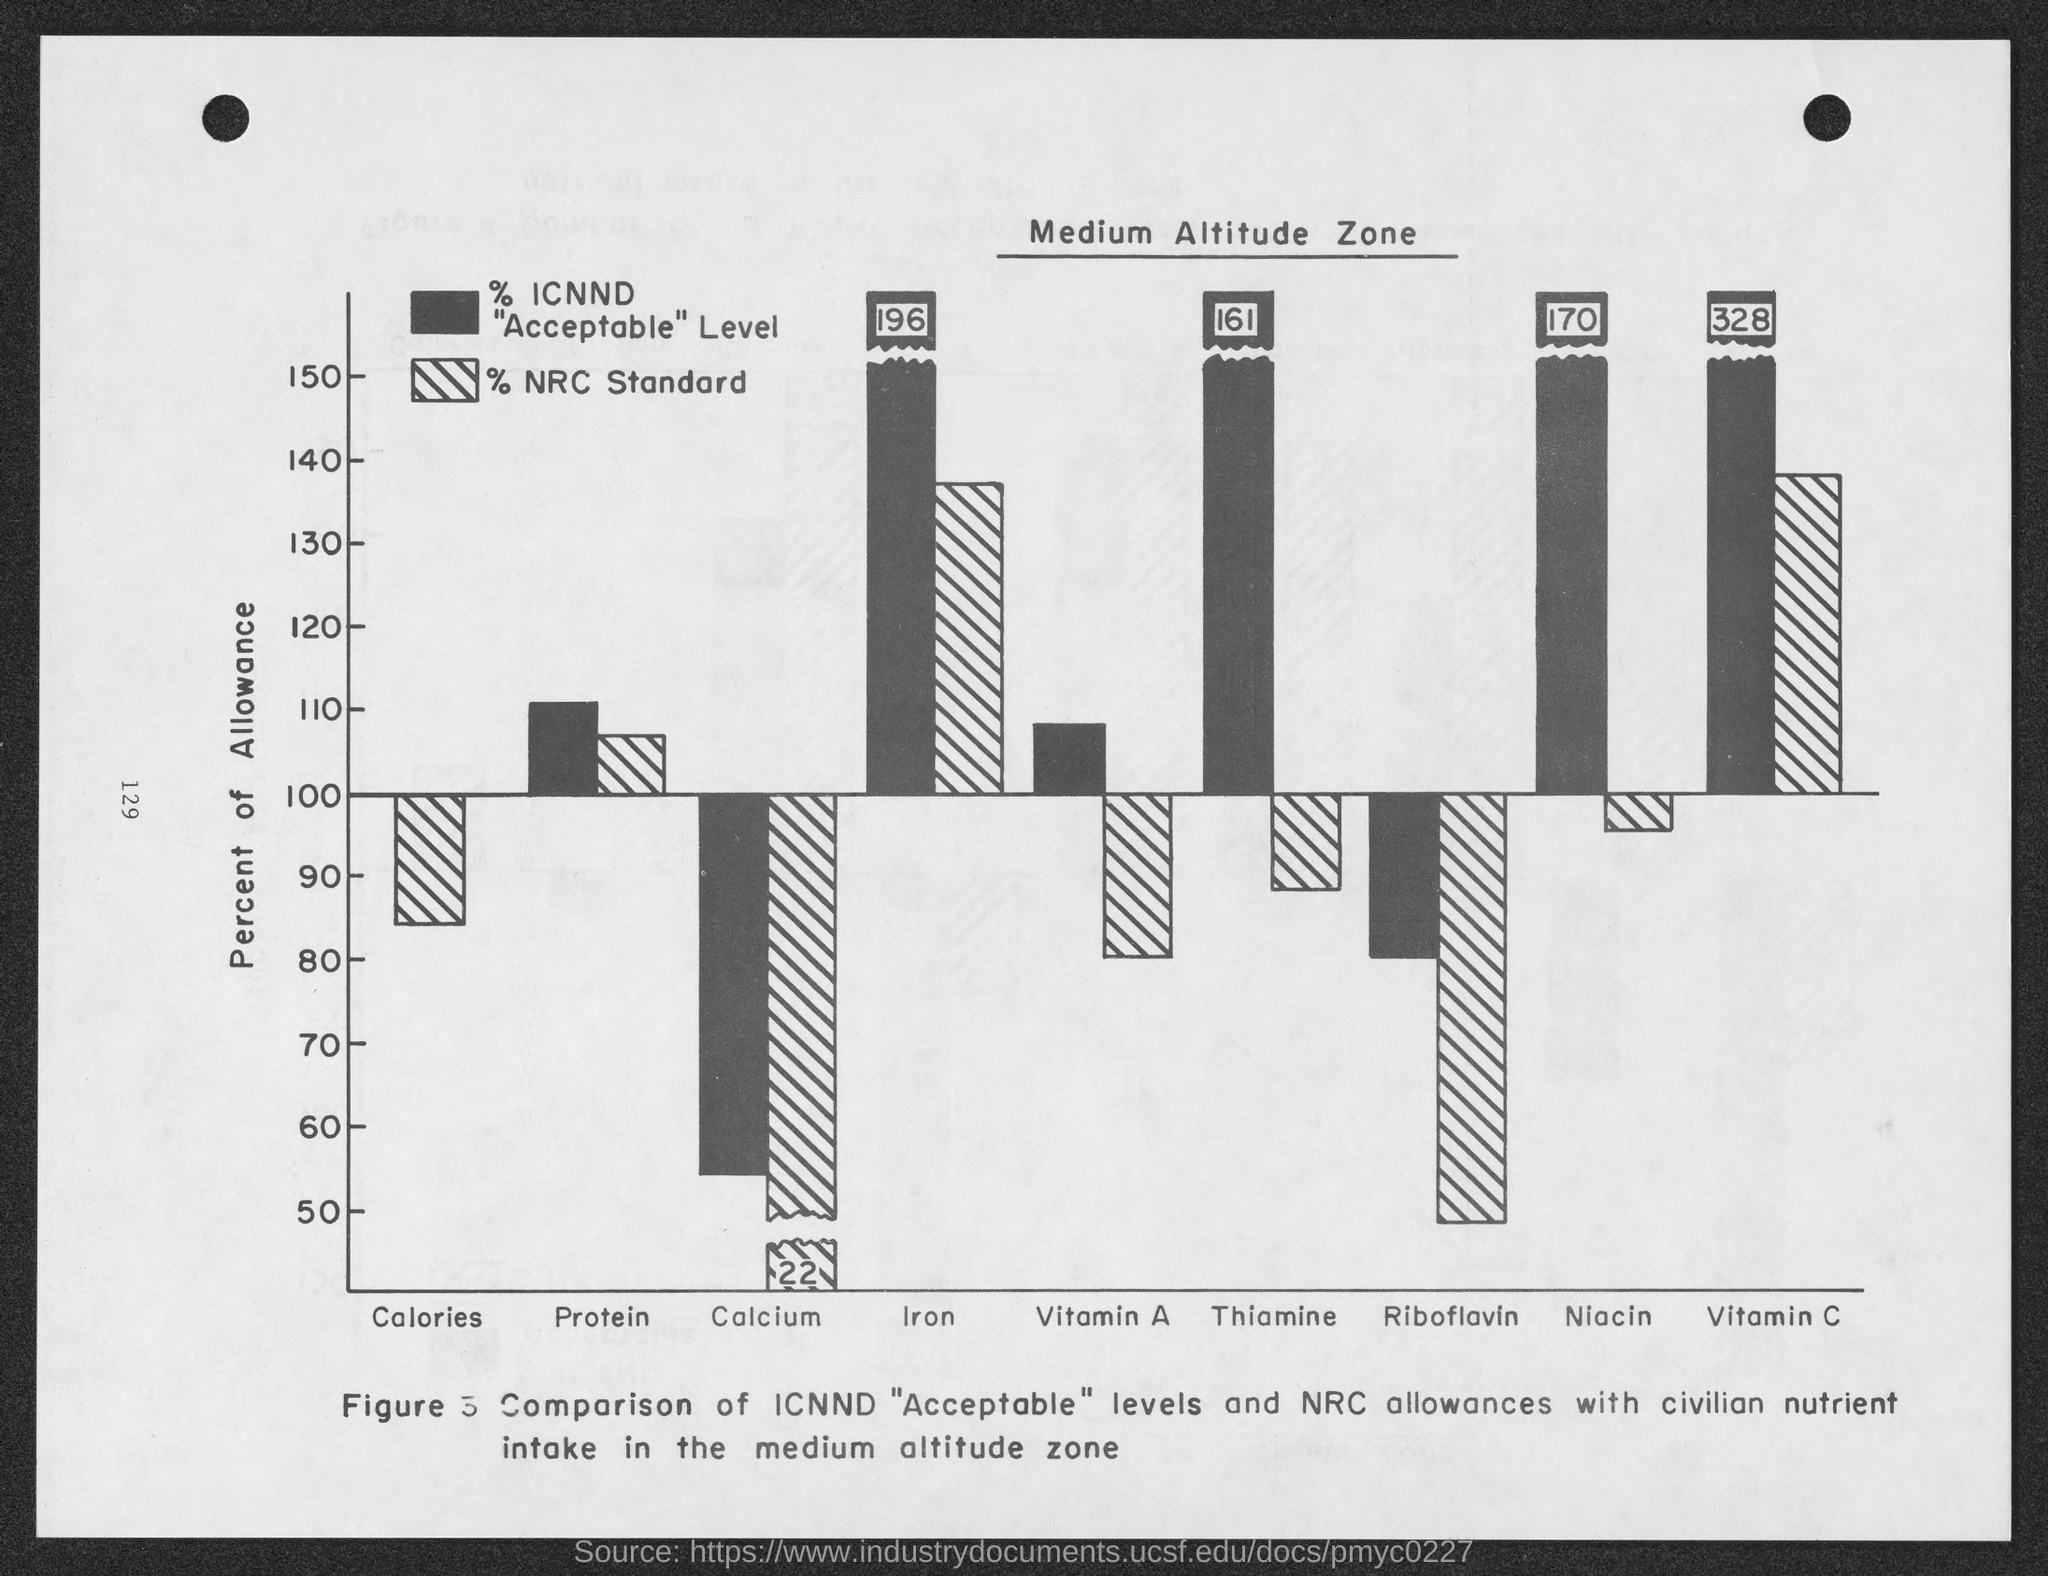Point out several critical features in this image. The first variable on the X axis is calories. The highest value on the Y axis is 150. The page title is "Medium Altitude Zone". In the graph, the Y axis represents the percentage of allowance. The last variable on the X axis is "Vitamin C. 